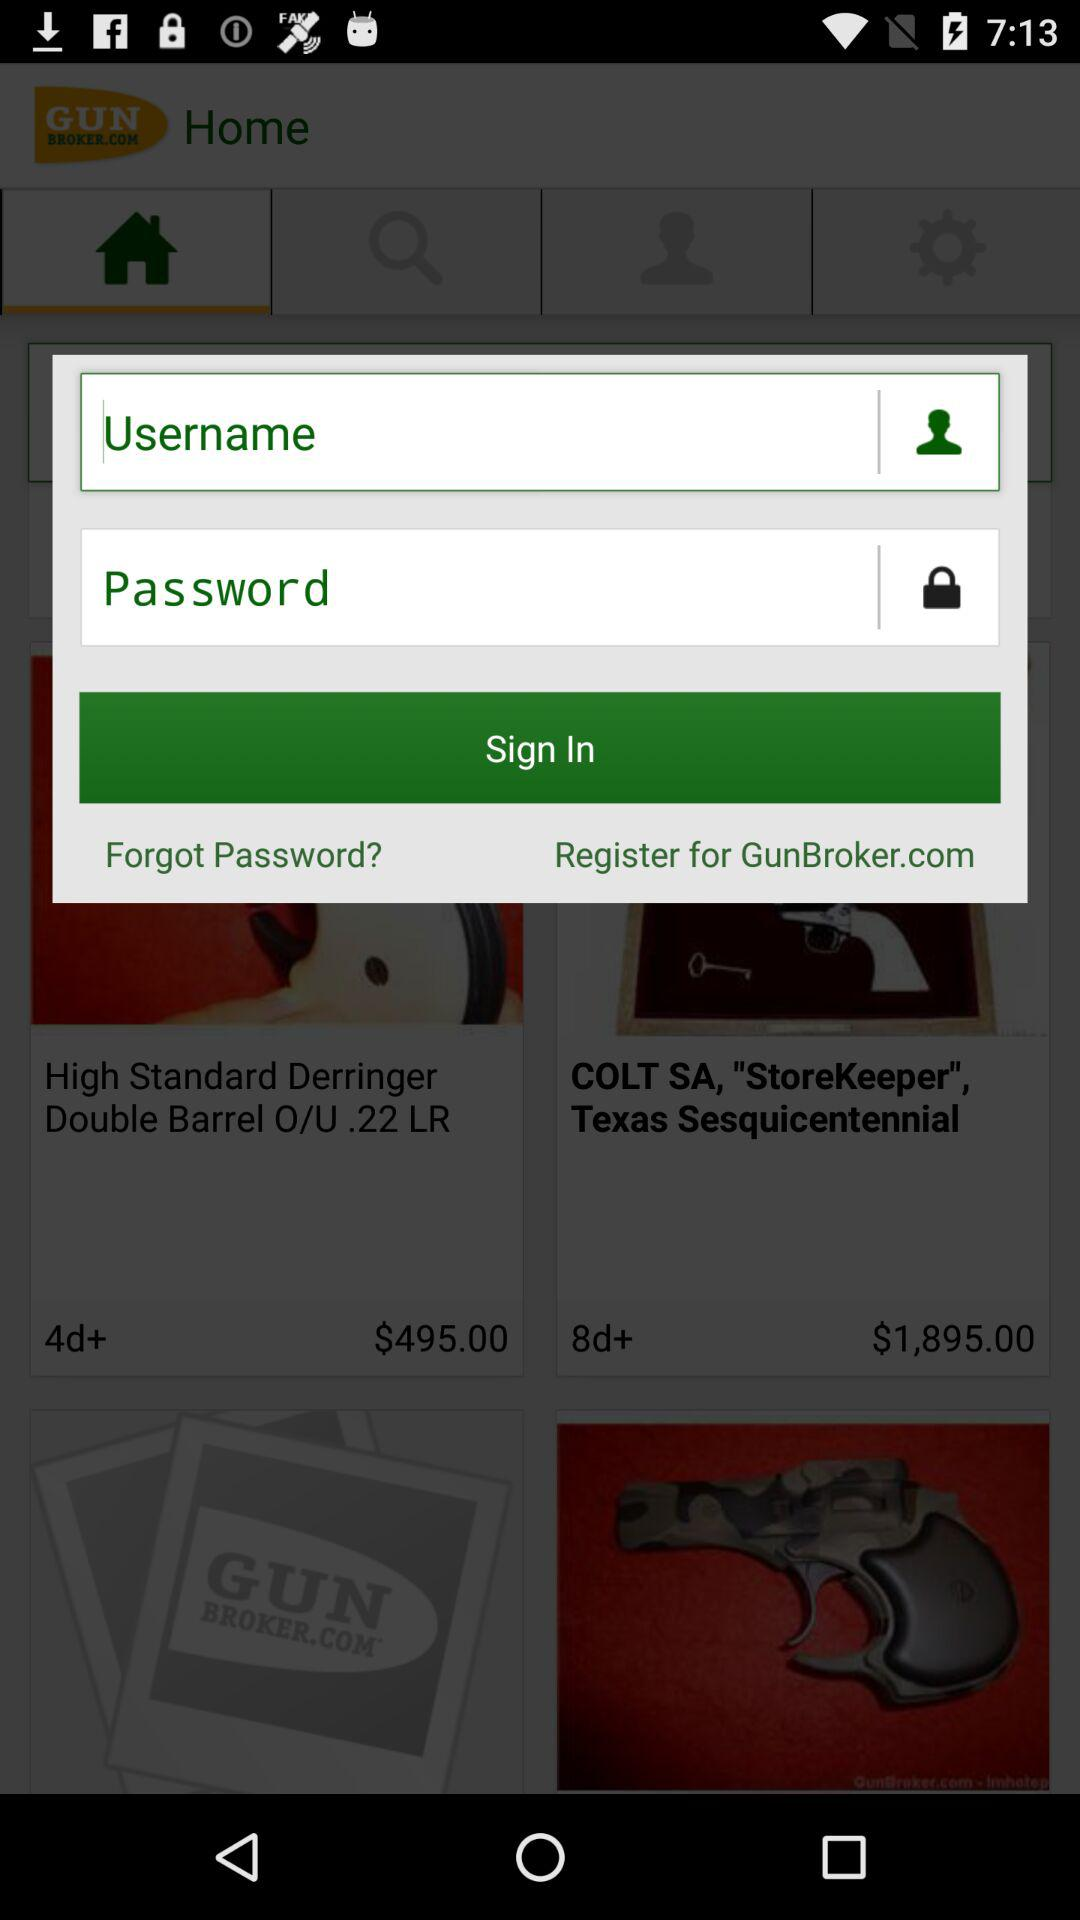What is the price of the Derringer Double Barrel O/U.22LR? The price is $495.00. 